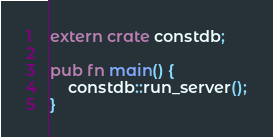<code> <loc_0><loc_0><loc_500><loc_500><_Rust_>extern crate constdb;

pub fn main() {
    constdb::run_server();
}</code> 